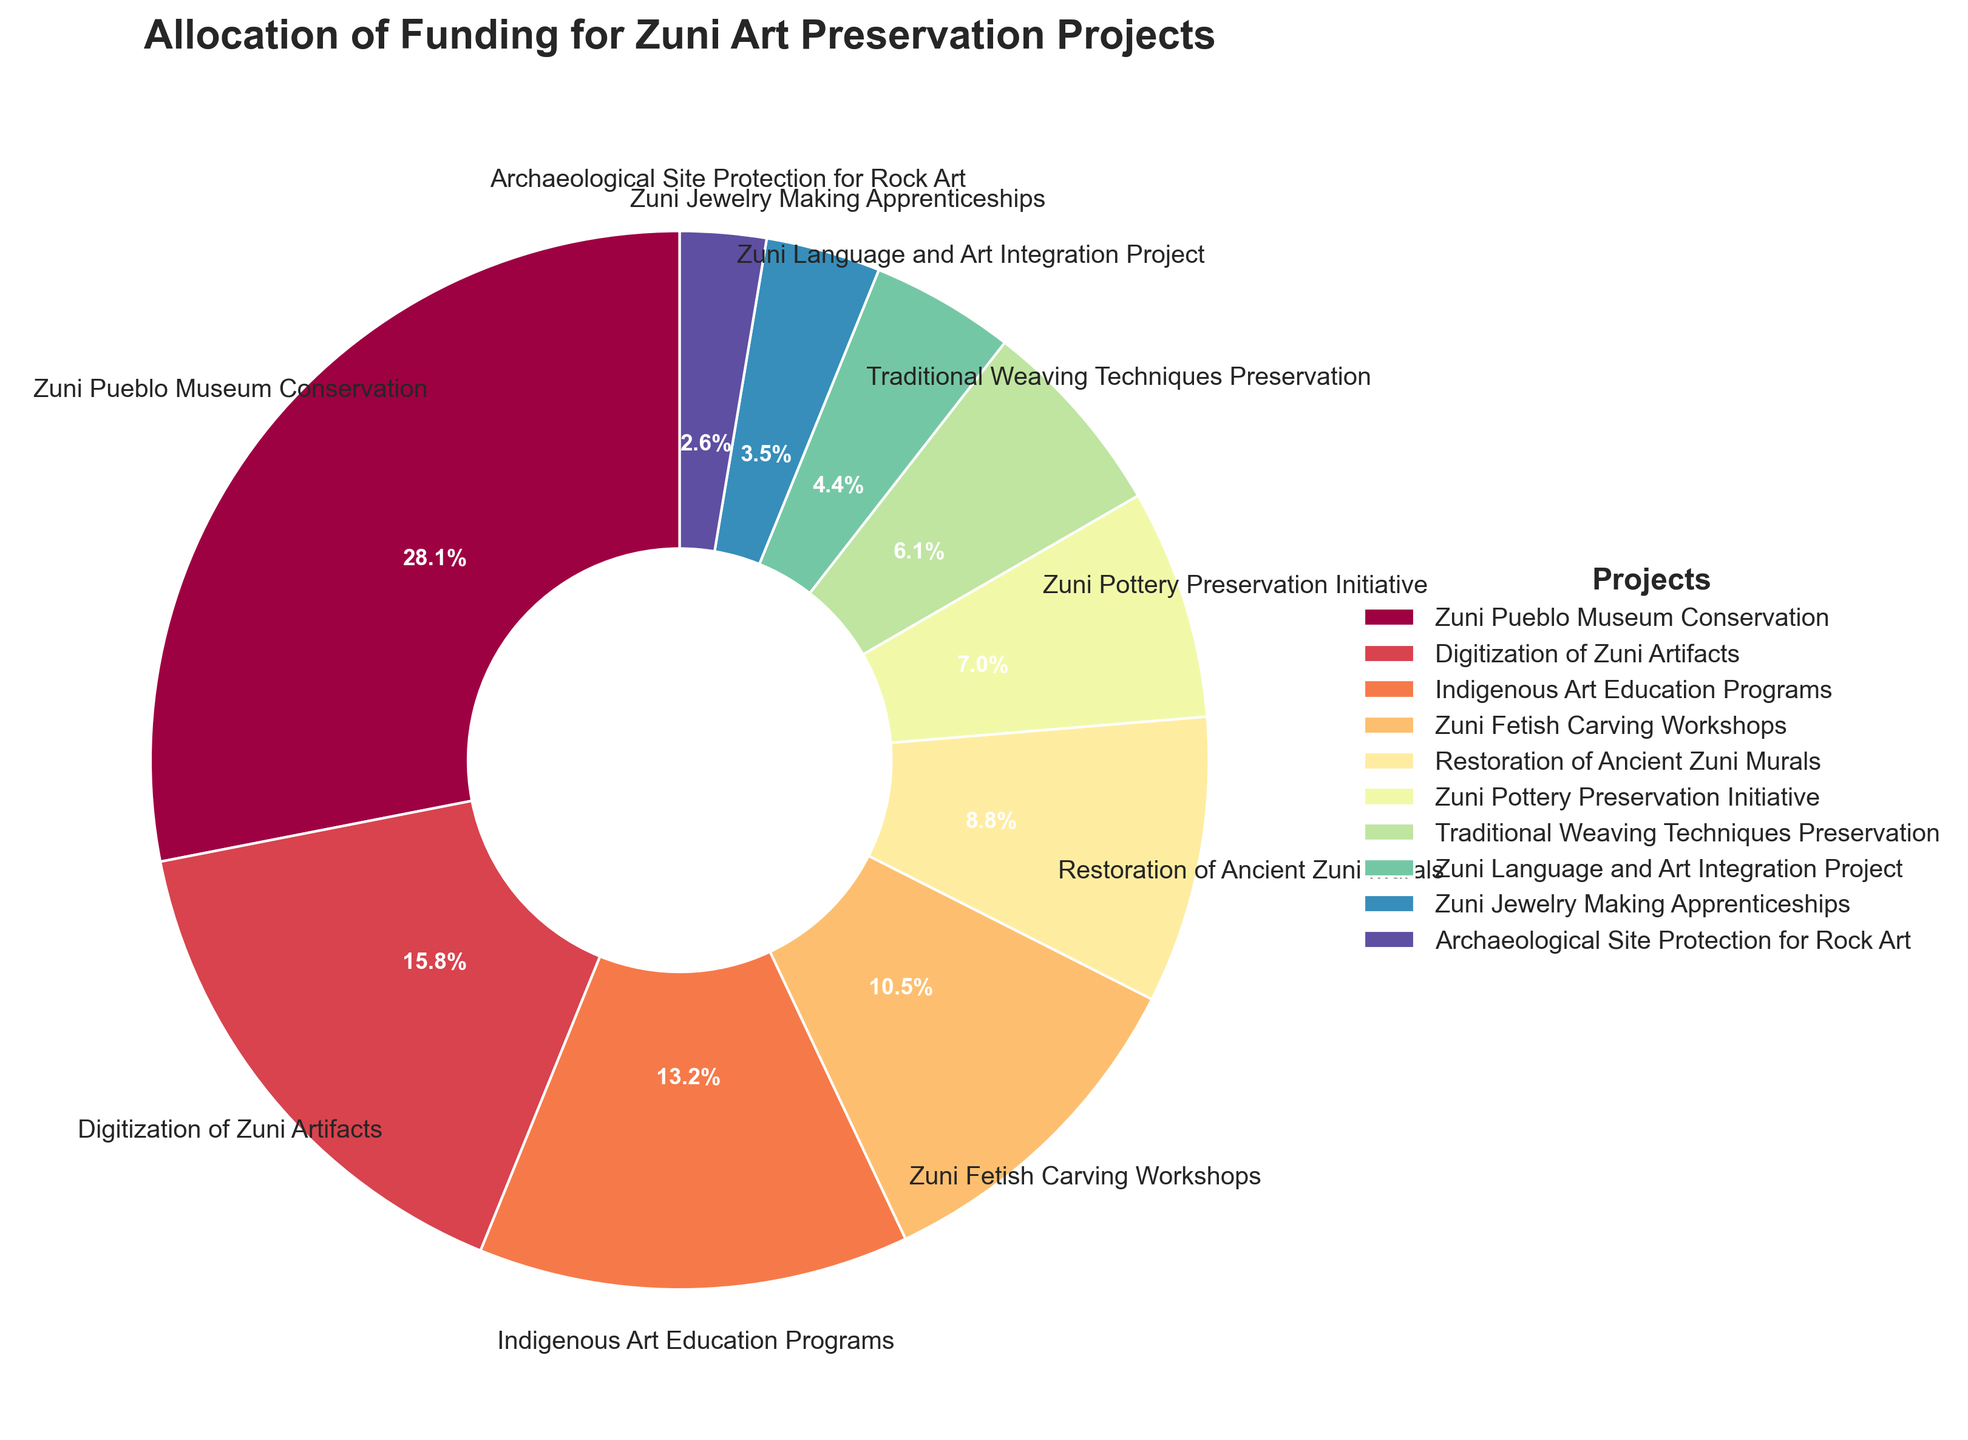What percentage of funding is allocated to the Zuni Pueblo Museum Conservation? Look for the segment labeled "Zuni Pueblo Museum Conservation" in the pie chart and read its percentage.
Answer: 32% How much larger is the funding allocation for the Zuni Pueblo Museum Conservation compared to the Zuni Fetish Carving Workshops? The pie chart indicates that Zuni Pueblo Museum Conservation has 32% while Zuni Fetish Carving Workshops has 12%. Subtract 12% from 32%. 32% - 12% = 20%.
Answer: 20% Which project receives the least amount of funding? Identify the smallest segment in the pie chart. The wedge labeled "Archaeological Site Protection for Rock Art" is the smallest.
Answer: Archaeological Site Protection for Rock Art What is the combined funding allocation percentage for Restoration of Ancient Zuni Murals and Zuni Pottery Preservation Initiative? Find the percentages for the two projects. Restoration of Ancient Zuni Murals is 10% and Zuni Pottery Preservation Initiative is 8%. Sum these values: 10% + 8% = 18%.
Answer: 18% Is the funding for Digitization of Zuni Artifacts greater than the funding for Indigenous Art Education Programs? Refer to the wedges labeled "Digitization of Zuni Artifacts" (18%) and "Indigenous Art Education Programs" (15%). Compare the two percentages.
Answer: Yes How much less funding does the Traditional Weaving Techniques Preservation project receive than the Indigenous Art Education Programs? Compare Traditional Weaving Techniques Preservation's 7% to Indigenous Art Education Program's 15%. Subtract 7% from 15%. 15% - 7% = 8%.
Answer: 8% Which three projects combined make up approximately half of the total funding allocation? Look for the three largest percentages that add up to roughly 50%. These are Zuni Pueblo Museum Conservation (32%), Digitization of Zuni Artifacts (18%), and Indigenous Art Education Programs (15%). 32% + 18% + 15% = 65% (which exceeds 50%, but combining smaller projects will not get closer to 50%). So the three largest are the closest representation.
Answer: Zuni Pueblo Museum Conservation, Digitization of Zuni Artifacts, Indigenous Art Education Programs What is the difference in funding allocation between the Zuni Language and Art Integration Project and the Zuni Jewelry Making Apprenticeships? Compare Zuni Language and Art Integration Project's 5% to Zuni Jewelry Making Apprenticeships' 4%. Subtract 4% from 5%. 5% - 4% = 1%.
Answer: 1% What is the funding allocation for the Zuni Pueblo Museum Conservation compared to the combined funding for Traditional Weaving Techniques Preservation and Zuni Language and Art Integration Project? Compare Zuni Pueblo Museum Conservation's 32% to the sum of Traditional Weaving Techniques Preservation (7%) and Zuni Language and Art Integration Project (5%). 7% + 5% = 12%. Then compare 32% to 12%. 32% is much larger.
Answer: 32% is much larger 